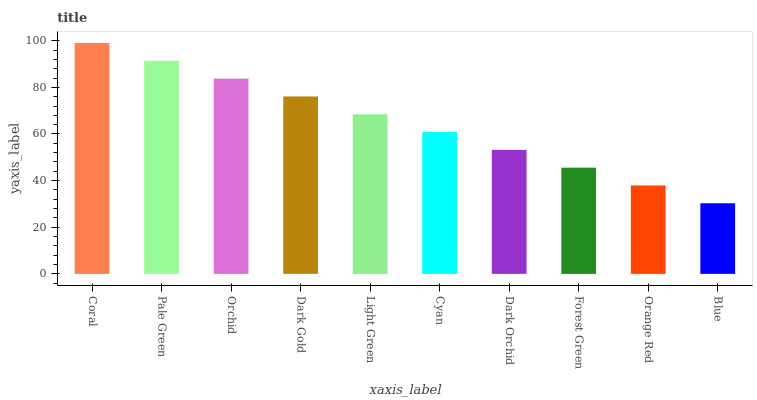Is Blue the minimum?
Answer yes or no. Yes. Is Coral the maximum?
Answer yes or no. Yes. Is Pale Green the minimum?
Answer yes or no. No. Is Pale Green the maximum?
Answer yes or no. No. Is Coral greater than Pale Green?
Answer yes or no. Yes. Is Pale Green less than Coral?
Answer yes or no. Yes. Is Pale Green greater than Coral?
Answer yes or no. No. Is Coral less than Pale Green?
Answer yes or no. No. Is Light Green the high median?
Answer yes or no. Yes. Is Cyan the low median?
Answer yes or no. Yes. Is Orange Red the high median?
Answer yes or no. No. Is Coral the low median?
Answer yes or no. No. 